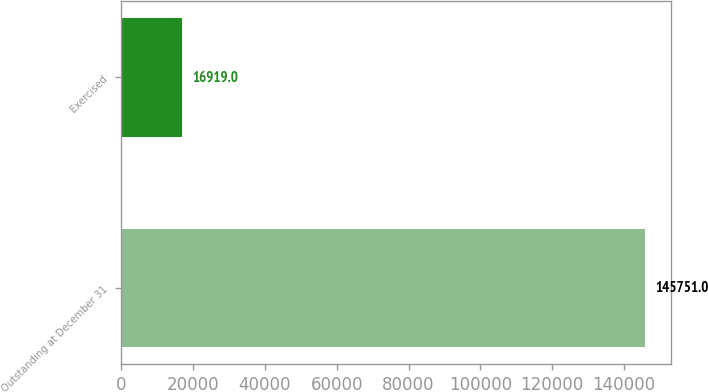Convert chart. <chart><loc_0><loc_0><loc_500><loc_500><bar_chart><fcel>Outstanding at December 31<fcel>Exercised<nl><fcel>145751<fcel>16919<nl></chart> 